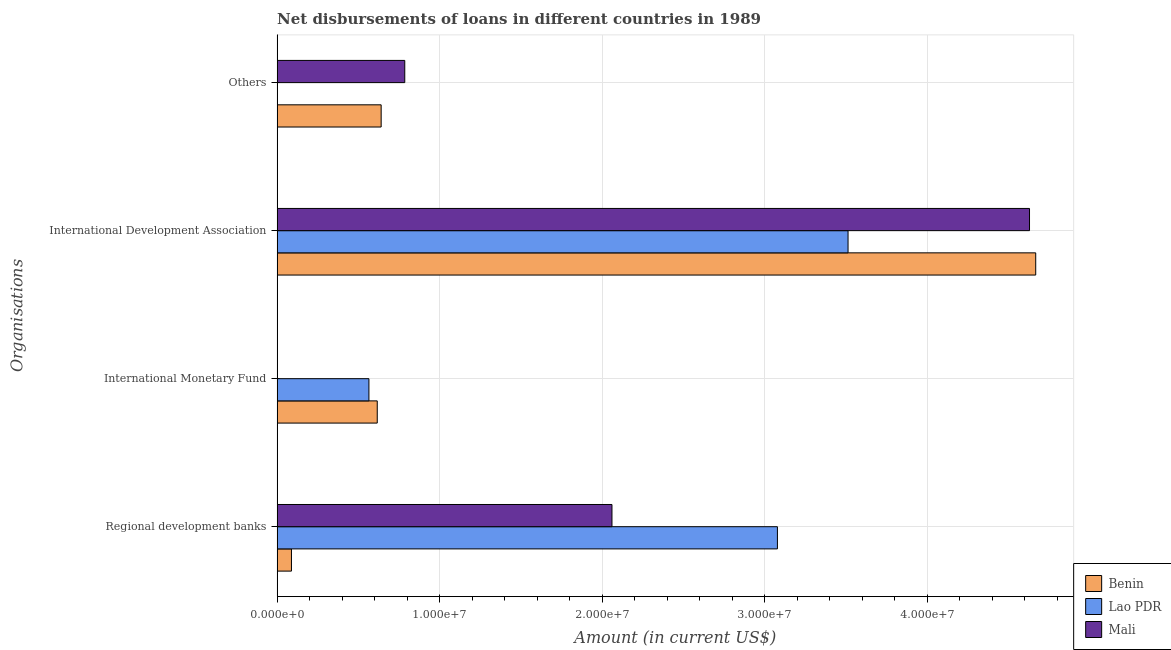Are the number of bars per tick equal to the number of legend labels?
Give a very brief answer. No. Are the number of bars on each tick of the Y-axis equal?
Ensure brevity in your answer.  No. What is the label of the 4th group of bars from the top?
Provide a succinct answer. Regional development banks. What is the amount of loan disimbursed by international development association in Benin?
Give a very brief answer. 4.67e+07. Across all countries, what is the maximum amount of loan disimbursed by international development association?
Provide a short and direct response. 4.67e+07. Across all countries, what is the minimum amount of loan disimbursed by other organisations?
Your response must be concise. 0. In which country was the amount of loan disimbursed by international monetary fund maximum?
Provide a short and direct response. Benin. What is the total amount of loan disimbursed by international development association in the graph?
Your answer should be very brief. 1.28e+08. What is the difference between the amount of loan disimbursed by international monetary fund in Lao PDR and that in Benin?
Keep it short and to the point. -5.13e+05. What is the difference between the amount of loan disimbursed by regional development banks in Benin and the amount of loan disimbursed by other organisations in Lao PDR?
Provide a short and direct response. 8.82e+05. What is the average amount of loan disimbursed by international monetary fund per country?
Keep it short and to the point. 3.94e+06. What is the difference between the amount of loan disimbursed by international development association and amount of loan disimbursed by regional development banks in Benin?
Offer a terse response. 4.58e+07. In how many countries, is the amount of loan disimbursed by other organisations greater than 8000000 US$?
Offer a terse response. 0. What is the ratio of the amount of loan disimbursed by regional development banks in Lao PDR to that in Mali?
Your response must be concise. 1.49. Is the difference between the amount of loan disimbursed by regional development banks in Benin and Lao PDR greater than the difference between the amount of loan disimbursed by international development association in Benin and Lao PDR?
Offer a terse response. No. What is the difference between the highest and the second highest amount of loan disimbursed by regional development banks?
Ensure brevity in your answer.  1.02e+07. What is the difference between the highest and the lowest amount of loan disimbursed by other organisations?
Your answer should be very brief. 7.86e+06. In how many countries, is the amount of loan disimbursed by other organisations greater than the average amount of loan disimbursed by other organisations taken over all countries?
Offer a very short reply. 2. Is the sum of the amount of loan disimbursed by regional development banks in Benin and Lao PDR greater than the maximum amount of loan disimbursed by other organisations across all countries?
Offer a terse response. Yes. Is it the case that in every country, the sum of the amount of loan disimbursed by regional development banks and amount of loan disimbursed by international monetary fund is greater than the amount of loan disimbursed by international development association?
Your answer should be very brief. No. Are all the bars in the graph horizontal?
Your answer should be very brief. Yes. What is the difference between two consecutive major ticks on the X-axis?
Keep it short and to the point. 1.00e+07. Does the graph contain any zero values?
Provide a succinct answer. Yes. Does the graph contain grids?
Give a very brief answer. Yes. Where does the legend appear in the graph?
Your answer should be very brief. Bottom right. How are the legend labels stacked?
Ensure brevity in your answer.  Vertical. What is the title of the graph?
Your answer should be compact. Net disbursements of loans in different countries in 1989. Does "Bolivia" appear as one of the legend labels in the graph?
Make the answer very short. No. What is the label or title of the Y-axis?
Your answer should be compact. Organisations. What is the Amount (in current US$) in Benin in Regional development banks?
Your response must be concise. 8.82e+05. What is the Amount (in current US$) in Lao PDR in Regional development banks?
Provide a short and direct response. 3.08e+07. What is the Amount (in current US$) of Mali in Regional development banks?
Your response must be concise. 2.06e+07. What is the Amount (in current US$) of Benin in International Monetary Fund?
Keep it short and to the point. 6.16e+06. What is the Amount (in current US$) in Lao PDR in International Monetary Fund?
Ensure brevity in your answer.  5.65e+06. What is the Amount (in current US$) in Mali in International Monetary Fund?
Offer a terse response. 0. What is the Amount (in current US$) in Benin in International Development Association?
Your response must be concise. 4.67e+07. What is the Amount (in current US$) in Lao PDR in International Development Association?
Offer a very short reply. 3.51e+07. What is the Amount (in current US$) in Mali in International Development Association?
Provide a succinct answer. 4.63e+07. What is the Amount (in current US$) of Benin in Others?
Provide a short and direct response. 6.40e+06. What is the Amount (in current US$) of Mali in Others?
Offer a very short reply. 7.86e+06. Across all Organisations, what is the maximum Amount (in current US$) of Benin?
Offer a very short reply. 4.67e+07. Across all Organisations, what is the maximum Amount (in current US$) of Lao PDR?
Give a very brief answer. 3.51e+07. Across all Organisations, what is the maximum Amount (in current US$) in Mali?
Make the answer very short. 4.63e+07. Across all Organisations, what is the minimum Amount (in current US$) of Benin?
Provide a succinct answer. 8.82e+05. Across all Organisations, what is the minimum Amount (in current US$) of Lao PDR?
Give a very brief answer. 0. What is the total Amount (in current US$) of Benin in the graph?
Ensure brevity in your answer.  6.01e+07. What is the total Amount (in current US$) of Lao PDR in the graph?
Provide a succinct answer. 7.16e+07. What is the total Amount (in current US$) of Mali in the graph?
Make the answer very short. 7.48e+07. What is the difference between the Amount (in current US$) in Benin in Regional development banks and that in International Monetary Fund?
Keep it short and to the point. -5.28e+06. What is the difference between the Amount (in current US$) of Lao PDR in Regional development banks and that in International Monetary Fund?
Provide a succinct answer. 2.51e+07. What is the difference between the Amount (in current US$) in Benin in Regional development banks and that in International Development Association?
Provide a short and direct response. -4.58e+07. What is the difference between the Amount (in current US$) in Lao PDR in Regional development banks and that in International Development Association?
Your answer should be compact. -4.35e+06. What is the difference between the Amount (in current US$) of Mali in Regional development banks and that in International Development Association?
Your answer should be very brief. -2.57e+07. What is the difference between the Amount (in current US$) of Benin in Regional development banks and that in Others?
Give a very brief answer. -5.52e+06. What is the difference between the Amount (in current US$) of Mali in Regional development banks and that in Others?
Make the answer very short. 1.28e+07. What is the difference between the Amount (in current US$) in Benin in International Monetary Fund and that in International Development Association?
Make the answer very short. -4.05e+07. What is the difference between the Amount (in current US$) in Lao PDR in International Monetary Fund and that in International Development Association?
Provide a short and direct response. -2.95e+07. What is the difference between the Amount (in current US$) of Benin in International Development Association and that in Others?
Provide a short and direct response. 4.03e+07. What is the difference between the Amount (in current US$) in Mali in International Development Association and that in Others?
Ensure brevity in your answer.  3.84e+07. What is the difference between the Amount (in current US$) of Benin in Regional development banks and the Amount (in current US$) of Lao PDR in International Monetary Fund?
Give a very brief answer. -4.77e+06. What is the difference between the Amount (in current US$) of Benin in Regional development banks and the Amount (in current US$) of Lao PDR in International Development Association?
Your answer should be very brief. -3.43e+07. What is the difference between the Amount (in current US$) of Benin in Regional development banks and the Amount (in current US$) of Mali in International Development Association?
Offer a terse response. -4.54e+07. What is the difference between the Amount (in current US$) of Lao PDR in Regional development banks and the Amount (in current US$) of Mali in International Development Association?
Keep it short and to the point. -1.55e+07. What is the difference between the Amount (in current US$) of Benin in Regional development banks and the Amount (in current US$) of Mali in Others?
Provide a succinct answer. -6.97e+06. What is the difference between the Amount (in current US$) of Lao PDR in Regional development banks and the Amount (in current US$) of Mali in Others?
Your answer should be compact. 2.29e+07. What is the difference between the Amount (in current US$) in Benin in International Monetary Fund and the Amount (in current US$) in Lao PDR in International Development Association?
Your answer should be very brief. -2.90e+07. What is the difference between the Amount (in current US$) in Benin in International Monetary Fund and the Amount (in current US$) in Mali in International Development Association?
Make the answer very short. -4.01e+07. What is the difference between the Amount (in current US$) of Lao PDR in International Monetary Fund and the Amount (in current US$) of Mali in International Development Association?
Offer a very short reply. -4.07e+07. What is the difference between the Amount (in current US$) in Benin in International Monetary Fund and the Amount (in current US$) in Mali in Others?
Your answer should be very brief. -1.69e+06. What is the difference between the Amount (in current US$) of Lao PDR in International Monetary Fund and the Amount (in current US$) of Mali in Others?
Keep it short and to the point. -2.21e+06. What is the difference between the Amount (in current US$) of Benin in International Development Association and the Amount (in current US$) of Mali in Others?
Provide a succinct answer. 3.88e+07. What is the difference between the Amount (in current US$) in Lao PDR in International Development Association and the Amount (in current US$) in Mali in Others?
Your response must be concise. 2.73e+07. What is the average Amount (in current US$) in Benin per Organisations?
Offer a very short reply. 1.50e+07. What is the average Amount (in current US$) in Lao PDR per Organisations?
Offer a terse response. 1.79e+07. What is the average Amount (in current US$) in Mali per Organisations?
Provide a succinct answer. 1.87e+07. What is the difference between the Amount (in current US$) of Benin and Amount (in current US$) of Lao PDR in Regional development banks?
Keep it short and to the point. -2.99e+07. What is the difference between the Amount (in current US$) of Benin and Amount (in current US$) of Mali in Regional development banks?
Your response must be concise. -1.97e+07. What is the difference between the Amount (in current US$) of Lao PDR and Amount (in current US$) of Mali in Regional development banks?
Offer a very short reply. 1.02e+07. What is the difference between the Amount (in current US$) in Benin and Amount (in current US$) in Lao PDR in International Monetary Fund?
Make the answer very short. 5.13e+05. What is the difference between the Amount (in current US$) in Benin and Amount (in current US$) in Lao PDR in International Development Association?
Provide a short and direct response. 1.15e+07. What is the difference between the Amount (in current US$) of Benin and Amount (in current US$) of Mali in International Development Association?
Your answer should be compact. 3.82e+05. What is the difference between the Amount (in current US$) in Lao PDR and Amount (in current US$) in Mali in International Development Association?
Make the answer very short. -1.12e+07. What is the difference between the Amount (in current US$) in Benin and Amount (in current US$) in Mali in Others?
Keep it short and to the point. -1.45e+06. What is the ratio of the Amount (in current US$) of Benin in Regional development banks to that in International Monetary Fund?
Your answer should be very brief. 0.14. What is the ratio of the Amount (in current US$) of Lao PDR in Regional development banks to that in International Monetary Fund?
Offer a very short reply. 5.45. What is the ratio of the Amount (in current US$) of Benin in Regional development banks to that in International Development Association?
Give a very brief answer. 0.02. What is the ratio of the Amount (in current US$) in Lao PDR in Regional development banks to that in International Development Association?
Keep it short and to the point. 0.88. What is the ratio of the Amount (in current US$) of Mali in Regional development banks to that in International Development Association?
Make the answer very short. 0.45. What is the ratio of the Amount (in current US$) of Benin in Regional development banks to that in Others?
Your answer should be compact. 0.14. What is the ratio of the Amount (in current US$) in Mali in Regional development banks to that in Others?
Ensure brevity in your answer.  2.62. What is the ratio of the Amount (in current US$) in Benin in International Monetary Fund to that in International Development Association?
Provide a short and direct response. 0.13. What is the ratio of the Amount (in current US$) in Lao PDR in International Monetary Fund to that in International Development Association?
Offer a terse response. 0.16. What is the ratio of the Amount (in current US$) in Benin in International Monetary Fund to that in Others?
Ensure brevity in your answer.  0.96. What is the ratio of the Amount (in current US$) of Benin in International Development Association to that in Others?
Offer a terse response. 7.29. What is the ratio of the Amount (in current US$) in Mali in International Development Association to that in Others?
Provide a short and direct response. 5.89. What is the difference between the highest and the second highest Amount (in current US$) in Benin?
Give a very brief answer. 4.03e+07. What is the difference between the highest and the second highest Amount (in current US$) of Lao PDR?
Your answer should be compact. 4.35e+06. What is the difference between the highest and the second highest Amount (in current US$) of Mali?
Your answer should be compact. 2.57e+07. What is the difference between the highest and the lowest Amount (in current US$) of Benin?
Offer a terse response. 4.58e+07. What is the difference between the highest and the lowest Amount (in current US$) of Lao PDR?
Your answer should be very brief. 3.51e+07. What is the difference between the highest and the lowest Amount (in current US$) of Mali?
Offer a very short reply. 4.63e+07. 